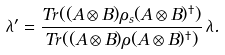<formula> <loc_0><loc_0><loc_500><loc_500>\lambda ^ { \prime } = \frac { T r ( ( A \otimes B ) \rho _ { s } ( A \otimes B ) ^ { \dag } ) } { T r ( ( A \otimes B ) \rho ( A \otimes B ) ^ { \dag } ) } \, \lambda .</formula> 